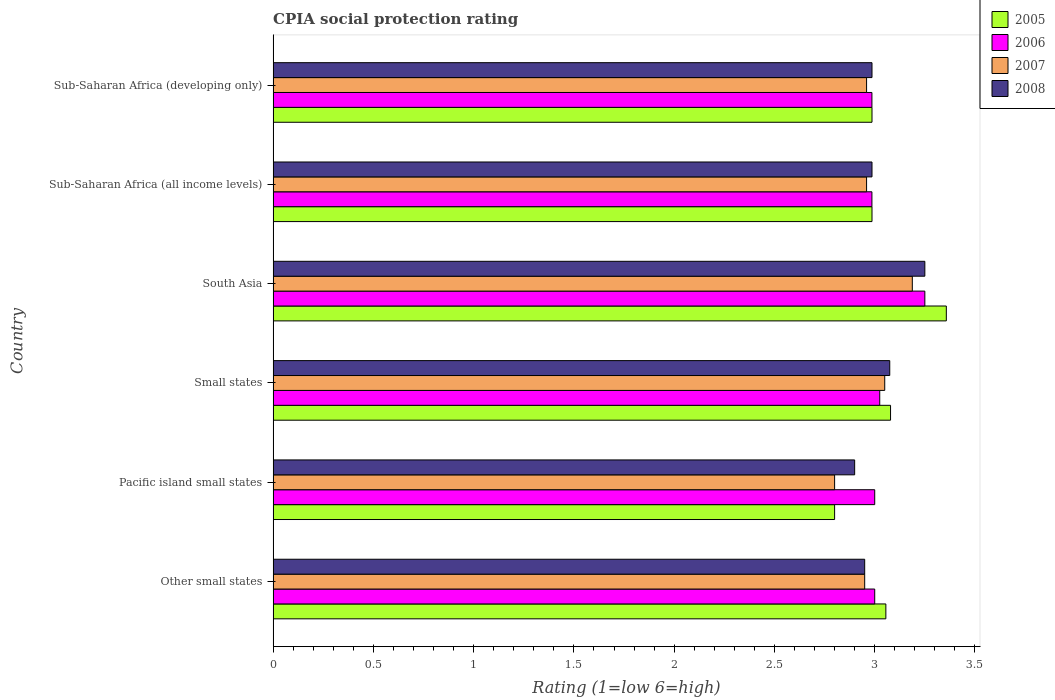How many groups of bars are there?
Your answer should be compact. 6. What is the label of the 6th group of bars from the top?
Offer a very short reply. Other small states. In how many cases, is the number of bars for a given country not equal to the number of legend labels?
Keep it short and to the point. 0. What is the CPIA rating in 2008 in Small states?
Give a very brief answer. 3.08. Across all countries, what is the maximum CPIA rating in 2007?
Your response must be concise. 3.19. Across all countries, what is the minimum CPIA rating in 2006?
Your answer should be compact. 2.99. In which country was the CPIA rating in 2008 maximum?
Offer a terse response. South Asia. In which country was the CPIA rating in 2005 minimum?
Offer a very short reply. Pacific island small states. What is the total CPIA rating in 2007 in the graph?
Your answer should be compact. 17.91. What is the difference between the CPIA rating in 2008 in Small states and that in Sub-Saharan Africa (developing only)?
Keep it short and to the point. 0.09. What is the difference between the CPIA rating in 2007 in South Asia and the CPIA rating in 2005 in Small states?
Provide a short and direct response. 0.11. What is the average CPIA rating in 2005 per country?
Provide a short and direct response. 3.04. What is the difference between the CPIA rating in 2007 and CPIA rating in 2005 in Other small states?
Give a very brief answer. -0.11. Is the CPIA rating in 2005 in Other small states less than that in Small states?
Make the answer very short. Yes. What is the difference between the highest and the second highest CPIA rating in 2007?
Keep it short and to the point. 0.14. What is the difference between the highest and the lowest CPIA rating in 2008?
Provide a short and direct response. 0.35. In how many countries, is the CPIA rating in 2006 greater than the average CPIA rating in 2006 taken over all countries?
Keep it short and to the point. 1. What does the 4th bar from the bottom in South Asia represents?
Provide a short and direct response. 2008. Is it the case that in every country, the sum of the CPIA rating in 2008 and CPIA rating in 2005 is greater than the CPIA rating in 2006?
Give a very brief answer. Yes. Are all the bars in the graph horizontal?
Provide a short and direct response. Yes. How many countries are there in the graph?
Keep it short and to the point. 6. Where does the legend appear in the graph?
Your answer should be very brief. Top right. What is the title of the graph?
Give a very brief answer. CPIA social protection rating. What is the label or title of the X-axis?
Your answer should be very brief. Rating (1=low 6=high). What is the Rating (1=low 6=high) in 2005 in Other small states?
Make the answer very short. 3.06. What is the Rating (1=low 6=high) of 2006 in Other small states?
Provide a succinct answer. 3. What is the Rating (1=low 6=high) of 2007 in Other small states?
Offer a terse response. 2.95. What is the Rating (1=low 6=high) of 2008 in Other small states?
Make the answer very short. 2.95. What is the Rating (1=low 6=high) in 2005 in Pacific island small states?
Your response must be concise. 2.8. What is the Rating (1=low 6=high) in 2006 in Pacific island small states?
Provide a succinct answer. 3. What is the Rating (1=low 6=high) in 2007 in Pacific island small states?
Offer a terse response. 2.8. What is the Rating (1=low 6=high) of 2008 in Pacific island small states?
Your answer should be very brief. 2.9. What is the Rating (1=low 6=high) in 2005 in Small states?
Provide a short and direct response. 3.08. What is the Rating (1=low 6=high) in 2006 in Small states?
Offer a very short reply. 3.02. What is the Rating (1=low 6=high) of 2007 in Small states?
Your answer should be compact. 3.05. What is the Rating (1=low 6=high) in 2008 in Small states?
Give a very brief answer. 3.08. What is the Rating (1=low 6=high) in 2005 in South Asia?
Give a very brief answer. 3.36. What is the Rating (1=low 6=high) of 2007 in South Asia?
Give a very brief answer. 3.19. What is the Rating (1=low 6=high) of 2005 in Sub-Saharan Africa (all income levels)?
Your answer should be compact. 2.99. What is the Rating (1=low 6=high) in 2006 in Sub-Saharan Africa (all income levels)?
Make the answer very short. 2.99. What is the Rating (1=low 6=high) of 2007 in Sub-Saharan Africa (all income levels)?
Give a very brief answer. 2.96. What is the Rating (1=low 6=high) in 2008 in Sub-Saharan Africa (all income levels)?
Provide a succinct answer. 2.99. What is the Rating (1=low 6=high) in 2005 in Sub-Saharan Africa (developing only)?
Your answer should be very brief. 2.99. What is the Rating (1=low 6=high) in 2006 in Sub-Saharan Africa (developing only)?
Provide a succinct answer. 2.99. What is the Rating (1=low 6=high) in 2007 in Sub-Saharan Africa (developing only)?
Give a very brief answer. 2.96. What is the Rating (1=low 6=high) of 2008 in Sub-Saharan Africa (developing only)?
Give a very brief answer. 2.99. Across all countries, what is the maximum Rating (1=low 6=high) of 2005?
Make the answer very short. 3.36. Across all countries, what is the maximum Rating (1=low 6=high) in 2006?
Provide a succinct answer. 3.25. Across all countries, what is the maximum Rating (1=low 6=high) in 2007?
Offer a terse response. 3.19. Across all countries, what is the maximum Rating (1=low 6=high) in 2008?
Offer a very short reply. 3.25. Across all countries, what is the minimum Rating (1=low 6=high) of 2006?
Keep it short and to the point. 2.99. Across all countries, what is the minimum Rating (1=low 6=high) of 2007?
Give a very brief answer. 2.8. Across all countries, what is the minimum Rating (1=low 6=high) of 2008?
Provide a succinct answer. 2.9. What is the total Rating (1=low 6=high) of 2005 in the graph?
Your answer should be very brief. 18.26. What is the total Rating (1=low 6=high) in 2006 in the graph?
Your answer should be compact. 18.25. What is the total Rating (1=low 6=high) in 2007 in the graph?
Your response must be concise. 17.91. What is the total Rating (1=low 6=high) in 2008 in the graph?
Give a very brief answer. 18.15. What is the difference between the Rating (1=low 6=high) of 2005 in Other small states and that in Pacific island small states?
Give a very brief answer. 0.26. What is the difference between the Rating (1=low 6=high) in 2006 in Other small states and that in Pacific island small states?
Your answer should be compact. 0. What is the difference between the Rating (1=low 6=high) of 2007 in Other small states and that in Pacific island small states?
Make the answer very short. 0.15. What is the difference between the Rating (1=low 6=high) of 2005 in Other small states and that in Small states?
Your answer should be compact. -0.02. What is the difference between the Rating (1=low 6=high) of 2006 in Other small states and that in Small states?
Provide a short and direct response. -0.03. What is the difference between the Rating (1=low 6=high) in 2008 in Other small states and that in Small states?
Your answer should be very brief. -0.12. What is the difference between the Rating (1=low 6=high) in 2005 in Other small states and that in South Asia?
Your response must be concise. -0.3. What is the difference between the Rating (1=low 6=high) in 2007 in Other small states and that in South Asia?
Make the answer very short. -0.24. What is the difference between the Rating (1=low 6=high) in 2008 in Other small states and that in South Asia?
Ensure brevity in your answer.  -0.3. What is the difference between the Rating (1=low 6=high) of 2005 in Other small states and that in Sub-Saharan Africa (all income levels)?
Your response must be concise. 0.07. What is the difference between the Rating (1=low 6=high) in 2006 in Other small states and that in Sub-Saharan Africa (all income levels)?
Your answer should be compact. 0.01. What is the difference between the Rating (1=low 6=high) in 2007 in Other small states and that in Sub-Saharan Africa (all income levels)?
Your answer should be compact. -0.01. What is the difference between the Rating (1=low 6=high) of 2008 in Other small states and that in Sub-Saharan Africa (all income levels)?
Ensure brevity in your answer.  -0.04. What is the difference between the Rating (1=low 6=high) of 2005 in Other small states and that in Sub-Saharan Africa (developing only)?
Provide a short and direct response. 0.07. What is the difference between the Rating (1=low 6=high) of 2006 in Other small states and that in Sub-Saharan Africa (developing only)?
Give a very brief answer. 0.01. What is the difference between the Rating (1=low 6=high) of 2007 in Other small states and that in Sub-Saharan Africa (developing only)?
Ensure brevity in your answer.  -0.01. What is the difference between the Rating (1=low 6=high) of 2008 in Other small states and that in Sub-Saharan Africa (developing only)?
Your response must be concise. -0.04. What is the difference between the Rating (1=low 6=high) in 2005 in Pacific island small states and that in Small states?
Provide a succinct answer. -0.28. What is the difference between the Rating (1=low 6=high) in 2006 in Pacific island small states and that in Small states?
Provide a succinct answer. -0.03. What is the difference between the Rating (1=low 6=high) in 2007 in Pacific island small states and that in Small states?
Keep it short and to the point. -0.25. What is the difference between the Rating (1=low 6=high) in 2008 in Pacific island small states and that in Small states?
Provide a succinct answer. -0.17. What is the difference between the Rating (1=low 6=high) of 2005 in Pacific island small states and that in South Asia?
Ensure brevity in your answer.  -0.56. What is the difference between the Rating (1=low 6=high) of 2007 in Pacific island small states and that in South Asia?
Keep it short and to the point. -0.39. What is the difference between the Rating (1=low 6=high) of 2008 in Pacific island small states and that in South Asia?
Your answer should be compact. -0.35. What is the difference between the Rating (1=low 6=high) in 2005 in Pacific island small states and that in Sub-Saharan Africa (all income levels)?
Offer a terse response. -0.19. What is the difference between the Rating (1=low 6=high) in 2006 in Pacific island small states and that in Sub-Saharan Africa (all income levels)?
Your answer should be compact. 0.01. What is the difference between the Rating (1=low 6=high) of 2007 in Pacific island small states and that in Sub-Saharan Africa (all income levels)?
Offer a very short reply. -0.16. What is the difference between the Rating (1=low 6=high) in 2008 in Pacific island small states and that in Sub-Saharan Africa (all income levels)?
Provide a succinct answer. -0.09. What is the difference between the Rating (1=low 6=high) in 2005 in Pacific island small states and that in Sub-Saharan Africa (developing only)?
Offer a terse response. -0.19. What is the difference between the Rating (1=low 6=high) of 2006 in Pacific island small states and that in Sub-Saharan Africa (developing only)?
Offer a very short reply. 0.01. What is the difference between the Rating (1=low 6=high) in 2007 in Pacific island small states and that in Sub-Saharan Africa (developing only)?
Make the answer very short. -0.16. What is the difference between the Rating (1=low 6=high) in 2008 in Pacific island small states and that in Sub-Saharan Africa (developing only)?
Your response must be concise. -0.09. What is the difference between the Rating (1=low 6=high) in 2005 in Small states and that in South Asia?
Your answer should be very brief. -0.28. What is the difference between the Rating (1=low 6=high) in 2006 in Small states and that in South Asia?
Your answer should be very brief. -0.23. What is the difference between the Rating (1=low 6=high) of 2007 in Small states and that in South Asia?
Your response must be concise. -0.14. What is the difference between the Rating (1=low 6=high) in 2008 in Small states and that in South Asia?
Provide a succinct answer. -0.17. What is the difference between the Rating (1=low 6=high) in 2005 in Small states and that in Sub-Saharan Africa (all income levels)?
Your answer should be very brief. 0.09. What is the difference between the Rating (1=low 6=high) in 2006 in Small states and that in Sub-Saharan Africa (all income levels)?
Give a very brief answer. 0.04. What is the difference between the Rating (1=low 6=high) in 2007 in Small states and that in Sub-Saharan Africa (all income levels)?
Your answer should be very brief. 0.09. What is the difference between the Rating (1=low 6=high) of 2008 in Small states and that in Sub-Saharan Africa (all income levels)?
Make the answer very short. 0.09. What is the difference between the Rating (1=low 6=high) in 2005 in Small states and that in Sub-Saharan Africa (developing only)?
Offer a terse response. 0.09. What is the difference between the Rating (1=low 6=high) of 2006 in Small states and that in Sub-Saharan Africa (developing only)?
Ensure brevity in your answer.  0.04. What is the difference between the Rating (1=low 6=high) in 2007 in Small states and that in Sub-Saharan Africa (developing only)?
Ensure brevity in your answer.  0.09. What is the difference between the Rating (1=low 6=high) of 2008 in Small states and that in Sub-Saharan Africa (developing only)?
Make the answer very short. 0.09. What is the difference between the Rating (1=low 6=high) of 2005 in South Asia and that in Sub-Saharan Africa (all income levels)?
Your answer should be compact. 0.37. What is the difference between the Rating (1=low 6=high) of 2006 in South Asia and that in Sub-Saharan Africa (all income levels)?
Make the answer very short. 0.26. What is the difference between the Rating (1=low 6=high) of 2007 in South Asia and that in Sub-Saharan Africa (all income levels)?
Your response must be concise. 0.23. What is the difference between the Rating (1=low 6=high) of 2008 in South Asia and that in Sub-Saharan Africa (all income levels)?
Your answer should be very brief. 0.26. What is the difference between the Rating (1=low 6=high) of 2005 in South Asia and that in Sub-Saharan Africa (developing only)?
Keep it short and to the point. 0.37. What is the difference between the Rating (1=low 6=high) in 2006 in South Asia and that in Sub-Saharan Africa (developing only)?
Your response must be concise. 0.26. What is the difference between the Rating (1=low 6=high) of 2007 in South Asia and that in Sub-Saharan Africa (developing only)?
Keep it short and to the point. 0.23. What is the difference between the Rating (1=low 6=high) of 2008 in South Asia and that in Sub-Saharan Africa (developing only)?
Give a very brief answer. 0.26. What is the difference between the Rating (1=low 6=high) of 2005 in Sub-Saharan Africa (all income levels) and that in Sub-Saharan Africa (developing only)?
Give a very brief answer. 0. What is the difference between the Rating (1=low 6=high) in 2006 in Sub-Saharan Africa (all income levels) and that in Sub-Saharan Africa (developing only)?
Give a very brief answer. 0. What is the difference between the Rating (1=low 6=high) in 2007 in Sub-Saharan Africa (all income levels) and that in Sub-Saharan Africa (developing only)?
Offer a terse response. 0. What is the difference between the Rating (1=low 6=high) of 2005 in Other small states and the Rating (1=low 6=high) of 2006 in Pacific island small states?
Ensure brevity in your answer.  0.06. What is the difference between the Rating (1=low 6=high) in 2005 in Other small states and the Rating (1=low 6=high) in 2007 in Pacific island small states?
Provide a succinct answer. 0.26. What is the difference between the Rating (1=low 6=high) of 2005 in Other small states and the Rating (1=low 6=high) of 2008 in Pacific island small states?
Provide a short and direct response. 0.16. What is the difference between the Rating (1=low 6=high) of 2006 in Other small states and the Rating (1=low 6=high) of 2008 in Pacific island small states?
Your response must be concise. 0.1. What is the difference between the Rating (1=low 6=high) of 2005 in Other small states and the Rating (1=low 6=high) of 2006 in Small states?
Make the answer very short. 0.03. What is the difference between the Rating (1=low 6=high) of 2005 in Other small states and the Rating (1=low 6=high) of 2007 in Small states?
Your answer should be compact. 0.01. What is the difference between the Rating (1=low 6=high) of 2005 in Other small states and the Rating (1=low 6=high) of 2008 in Small states?
Your answer should be compact. -0.02. What is the difference between the Rating (1=low 6=high) of 2006 in Other small states and the Rating (1=low 6=high) of 2007 in Small states?
Provide a succinct answer. -0.05. What is the difference between the Rating (1=low 6=high) of 2006 in Other small states and the Rating (1=low 6=high) of 2008 in Small states?
Your answer should be very brief. -0.07. What is the difference between the Rating (1=low 6=high) in 2007 in Other small states and the Rating (1=low 6=high) in 2008 in Small states?
Your response must be concise. -0.12. What is the difference between the Rating (1=low 6=high) in 2005 in Other small states and the Rating (1=low 6=high) in 2006 in South Asia?
Your answer should be very brief. -0.19. What is the difference between the Rating (1=low 6=high) of 2005 in Other small states and the Rating (1=low 6=high) of 2007 in South Asia?
Offer a very short reply. -0.13. What is the difference between the Rating (1=low 6=high) of 2005 in Other small states and the Rating (1=low 6=high) of 2008 in South Asia?
Give a very brief answer. -0.19. What is the difference between the Rating (1=low 6=high) of 2006 in Other small states and the Rating (1=low 6=high) of 2007 in South Asia?
Your response must be concise. -0.19. What is the difference between the Rating (1=low 6=high) of 2006 in Other small states and the Rating (1=low 6=high) of 2008 in South Asia?
Your answer should be compact. -0.25. What is the difference between the Rating (1=low 6=high) of 2007 in Other small states and the Rating (1=low 6=high) of 2008 in South Asia?
Your response must be concise. -0.3. What is the difference between the Rating (1=low 6=high) in 2005 in Other small states and the Rating (1=low 6=high) in 2006 in Sub-Saharan Africa (all income levels)?
Your answer should be compact. 0.07. What is the difference between the Rating (1=low 6=high) of 2005 in Other small states and the Rating (1=low 6=high) of 2007 in Sub-Saharan Africa (all income levels)?
Offer a very short reply. 0.1. What is the difference between the Rating (1=low 6=high) of 2005 in Other small states and the Rating (1=low 6=high) of 2008 in Sub-Saharan Africa (all income levels)?
Make the answer very short. 0.07. What is the difference between the Rating (1=low 6=high) of 2006 in Other small states and the Rating (1=low 6=high) of 2007 in Sub-Saharan Africa (all income levels)?
Offer a terse response. 0.04. What is the difference between the Rating (1=low 6=high) in 2006 in Other small states and the Rating (1=low 6=high) in 2008 in Sub-Saharan Africa (all income levels)?
Give a very brief answer. 0.01. What is the difference between the Rating (1=low 6=high) in 2007 in Other small states and the Rating (1=low 6=high) in 2008 in Sub-Saharan Africa (all income levels)?
Your answer should be very brief. -0.04. What is the difference between the Rating (1=low 6=high) in 2005 in Other small states and the Rating (1=low 6=high) in 2006 in Sub-Saharan Africa (developing only)?
Keep it short and to the point. 0.07. What is the difference between the Rating (1=low 6=high) in 2005 in Other small states and the Rating (1=low 6=high) in 2007 in Sub-Saharan Africa (developing only)?
Ensure brevity in your answer.  0.1. What is the difference between the Rating (1=low 6=high) of 2005 in Other small states and the Rating (1=low 6=high) of 2008 in Sub-Saharan Africa (developing only)?
Your answer should be very brief. 0.07. What is the difference between the Rating (1=low 6=high) in 2006 in Other small states and the Rating (1=low 6=high) in 2007 in Sub-Saharan Africa (developing only)?
Provide a short and direct response. 0.04. What is the difference between the Rating (1=low 6=high) of 2006 in Other small states and the Rating (1=low 6=high) of 2008 in Sub-Saharan Africa (developing only)?
Make the answer very short. 0.01. What is the difference between the Rating (1=low 6=high) of 2007 in Other small states and the Rating (1=low 6=high) of 2008 in Sub-Saharan Africa (developing only)?
Give a very brief answer. -0.04. What is the difference between the Rating (1=low 6=high) in 2005 in Pacific island small states and the Rating (1=low 6=high) in 2006 in Small states?
Your response must be concise. -0.23. What is the difference between the Rating (1=low 6=high) in 2005 in Pacific island small states and the Rating (1=low 6=high) in 2008 in Small states?
Your answer should be compact. -0.28. What is the difference between the Rating (1=low 6=high) in 2006 in Pacific island small states and the Rating (1=low 6=high) in 2008 in Small states?
Keep it short and to the point. -0.07. What is the difference between the Rating (1=low 6=high) of 2007 in Pacific island small states and the Rating (1=low 6=high) of 2008 in Small states?
Ensure brevity in your answer.  -0.28. What is the difference between the Rating (1=low 6=high) in 2005 in Pacific island small states and the Rating (1=low 6=high) in 2006 in South Asia?
Your answer should be compact. -0.45. What is the difference between the Rating (1=low 6=high) of 2005 in Pacific island small states and the Rating (1=low 6=high) of 2007 in South Asia?
Make the answer very short. -0.39. What is the difference between the Rating (1=low 6=high) of 2005 in Pacific island small states and the Rating (1=low 6=high) of 2008 in South Asia?
Provide a succinct answer. -0.45. What is the difference between the Rating (1=low 6=high) in 2006 in Pacific island small states and the Rating (1=low 6=high) in 2007 in South Asia?
Your answer should be compact. -0.19. What is the difference between the Rating (1=low 6=high) in 2006 in Pacific island small states and the Rating (1=low 6=high) in 2008 in South Asia?
Your answer should be compact. -0.25. What is the difference between the Rating (1=low 6=high) in 2007 in Pacific island small states and the Rating (1=low 6=high) in 2008 in South Asia?
Keep it short and to the point. -0.45. What is the difference between the Rating (1=low 6=high) in 2005 in Pacific island small states and the Rating (1=low 6=high) in 2006 in Sub-Saharan Africa (all income levels)?
Provide a succinct answer. -0.19. What is the difference between the Rating (1=low 6=high) in 2005 in Pacific island small states and the Rating (1=low 6=high) in 2007 in Sub-Saharan Africa (all income levels)?
Your answer should be compact. -0.16. What is the difference between the Rating (1=low 6=high) in 2005 in Pacific island small states and the Rating (1=low 6=high) in 2008 in Sub-Saharan Africa (all income levels)?
Your answer should be compact. -0.19. What is the difference between the Rating (1=low 6=high) of 2006 in Pacific island small states and the Rating (1=low 6=high) of 2007 in Sub-Saharan Africa (all income levels)?
Your answer should be compact. 0.04. What is the difference between the Rating (1=low 6=high) in 2006 in Pacific island small states and the Rating (1=low 6=high) in 2008 in Sub-Saharan Africa (all income levels)?
Make the answer very short. 0.01. What is the difference between the Rating (1=low 6=high) in 2007 in Pacific island small states and the Rating (1=low 6=high) in 2008 in Sub-Saharan Africa (all income levels)?
Provide a succinct answer. -0.19. What is the difference between the Rating (1=low 6=high) of 2005 in Pacific island small states and the Rating (1=low 6=high) of 2006 in Sub-Saharan Africa (developing only)?
Keep it short and to the point. -0.19. What is the difference between the Rating (1=low 6=high) of 2005 in Pacific island small states and the Rating (1=low 6=high) of 2007 in Sub-Saharan Africa (developing only)?
Offer a terse response. -0.16. What is the difference between the Rating (1=low 6=high) in 2005 in Pacific island small states and the Rating (1=low 6=high) in 2008 in Sub-Saharan Africa (developing only)?
Offer a very short reply. -0.19. What is the difference between the Rating (1=low 6=high) in 2006 in Pacific island small states and the Rating (1=low 6=high) in 2007 in Sub-Saharan Africa (developing only)?
Your answer should be compact. 0.04. What is the difference between the Rating (1=low 6=high) of 2006 in Pacific island small states and the Rating (1=low 6=high) of 2008 in Sub-Saharan Africa (developing only)?
Your answer should be very brief. 0.01. What is the difference between the Rating (1=low 6=high) of 2007 in Pacific island small states and the Rating (1=low 6=high) of 2008 in Sub-Saharan Africa (developing only)?
Make the answer very short. -0.19. What is the difference between the Rating (1=low 6=high) of 2005 in Small states and the Rating (1=low 6=high) of 2006 in South Asia?
Your answer should be compact. -0.17. What is the difference between the Rating (1=low 6=high) of 2005 in Small states and the Rating (1=low 6=high) of 2007 in South Asia?
Your answer should be very brief. -0.11. What is the difference between the Rating (1=low 6=high) in 2005 in Small states and the Rating (1=low 6=high) in 2008 in South Asia?
Offer a terse response. -0.17. What is the difference between the Rating (1=low 6=high) in 2006 in Small states and the Rating (1=low 6=high) in 2007 in South Asia?
Your answer should be compact. -0.16. What is the difference between the Rating (1=low 6=high) in 2006 in Small states and the Rating (1=low 6=high) in 2008 in South Asia?
Ensure brevity in your answer.  -0.23. What is the difference between the Rating (1=low 6=high) in 2005 in Small states and the Rating (1=low 6=high) in 2006 in Sub-Saharan Africa (all income levels)?
Your response must be concise. 0.09. What is the difference between the Rating (1=low 6=high) in 2005 in Small states and the Rating (1=low 6=high) in 2007 in Sub-Saharan Africa (all income levels)?
Give a very brief answer. 0.12. What is the difference between the Rating (1=low 6=high) of 2005 in Small states and the Rating (1=low 6=high) of 2008 in Sub-Saharan Africa (all income levels)?
Your answer should be compact. 0.09. What is the difference between the Rating (1=low 6=high) in 2006 in Small states and the Rating (1=low 6=high) in 2007 in Sub-Saharan Africa (all income levels)?
Ensure brevity in your answer.  0.07. What is the difference between the Rating (1=low 6=high) of 2006 in Small states and the Rating (1=low 6=high) of 2008 in Sub-Saharan Africa (all income levels)?
Keep it short and to the point. 0.04. What is the difference between the Rating (1=low 6=high) in 2007 in Small states and the Rating (1=low 6=high) in 2008 in Sub-Saharan Africa (all income levels)?
Your answer should be very brief. 0.06. What is the difference between the Rating (1=low 6=high) in 2005 in Small states and the Rating (1=low 6=high) in 2006 in Sub-Saharan Africa (developing only)?
Provide a succinct answer. 0.09. What is the difference between the Rating (1=low 6=high) in 2005 in Small states and the Rating (1=low 6=high) in 2007 in Sub-Saharan Africa (developing only)?
Provide a short and direct response. 0.12. What is the difference between the Rating (1=low 6=high) in 2005 in Small states and the Rating (1=low 6=high) in 2008 in Sub-Saharan Africa (developing only)?
Your answer should be very brief. 0.09. What is the difference between the Rating (1=low 6=high) in 2006 in Small states and the Rating (1=low 6=high) in 2007 in Sub-Saharan Africa (developing only)?
Your response must be concise. 0.07. What is the difference between the Rating (1=low 6=high) of 2006 in Small states and the Rating (1=low 6=high) of 2008 in Sub-Saharan Africa (developing only)?
Ensure brevity in your answer.  0.04. What is the difference between the Rating (1=low 6=high) in 2007 in Small states and the Rating (1=low 6=high) in 2008 in Sub-Saharan Africa (developing only)?
Give a very brief answer. 0.06. What is the difference between the Rating (1=low 6=high) of 2005 in South Asia and the Rating (1=low 6=high) of 2006 in Sub-Saharan Africa (all income levels)?
Your answer should be very brief. 0.37. What is the difference between the Rating (1=low 6=high) in 2005 in South Asia and the Rating (1=low 6=high) in 2007 in Sub-Saharan Africa (all income levels)?
Keep it short and to the point. 0.4. What is the difference between the Rating (1=low 6=high) of 2005 in South Asia and the Rating (1=low 6=high) of 2008 in Sub-Saharan Africa (all income levels)?
Your answer should be very brief. 0.37. What is the difference between the Rating (1=low 6=high) in 2006 in South Asia and the Rating (1=low 6=high) in 2007 in Sub-Saharan Africa (all income levels)?
Offer a very short reply. 0.29. What is the difference between the Rating (1=low 6=high) of 2006 in South Asia and the Rating (1=low 6=high) of 2008 in Sub-Saharan Africa (all income levels)?
Offer a very short reply. 0.26. What is the difference between the Rating (1=low 6=high) of 2007 in South Asia and the Rating (1=low 6=high) of 2008 in Sub-Saharan Africa (all income levels)?
Offer a very short reply. 0.2. What is the difference between the Rating (1=low 6=high) of 2005 in South Asia and the Rating (1=low 6=high) of 2006 in Sub-Saharan Africa (developing only)?
Ensure brevity in your answer.  0.37. What is the difference between the Rating (1=low 6=high) in 2005 in South Asia and the Rating (1=low 6=high) in 2007 in Sub-Saharan Africa (developing only)?
Offer a terse response. 0.4. What is the difference between the Rating (1=low 6=high) of 2005 in South Asia and the Rating (1=low 6=high) of 2008 in Sub-Saharan Africa (developing only)?
Provide a succinct answer. 0.37. What is the difference between the Rating (1=low 6=high) in 2006 in South Asia and the Rating (1=low 6=high) in 2007 in Sub-Saharan Africa (developing only)?
Offer a terse response. 0.29. What is the difference between the Rating (1=low 6=high) in 2006 in South Asia and the Rating (1=low 6=high) in 2008 in Sub-Saharan Africa (developing only)?
Make the answer very short. 0.26. What is the difference between the Rating (1=low 6=high) of 2007 in South Asia and the Rating (1=low 6=high) of 2008 in Sub-Saharan Africa (developing only)?
Offer a very short reply. 0.2. What is the difference between the Rating (1=low 6=high) in 2005 in Sub-Saharan Africa (all income levels) and the Rating (1=low 6=high) in 2006 in Sub-Saharan Africa (developing only)?
Keep it short and to the point. 0. What is the difference between the Rating (1=low 6=high) of 2005 in Sub-Saharan Africa (all income levels) and the Rating (1=low 6=high) of 2007 in Sub-Saharan Africa (developing only)?
Ensure brevity in your answer.  0.03. What is the difference between the Rating (1=low 6=high) of 2006 in Sub-Saharan Africa (all income levels) and the Rating (1=low 6=high) of 2007 in Sub-Saharan Africa (developing only)?
Provide a short and direct response. 0.03. What is the difference between the Rating (1=low 6=high) in 2006 in Sub-Saharan Africa (all income levels) and the Rating (1=low 6=high) in 2008 in Sub-Saharan Africa (developing only)?
Offer a terse response. -0. What is the difference between the Rating (1=low 6=high) in 2007 in Sub-Saharan Africa (all income levels) and the Rating (1=low 6=high) in 2008 in Sub-Saharan Africa (developing only)?
Your answer should be compact. -0.03. What is the average Rating (1=low 6=high) in 2005 per country?
Keep it short and to the point. 3.04. What is the average Rating (1=low 6=high) of 2006 per country?
Your answer should be very brief. 3.04. What is the average Rating (1=low 6=high) in 2007 per country?
Your answer should be very brief. 2.98. What is the average Rating (1=low 6=high) of 2008 per country?
Make the answer very short. 3.02. What is the difference between the Rating (1=low 6=high) in 2005 and Rating (1=low 6=high) in 2006 in Other small states?
Your answer should be very brief. 0.06. What is the difference between the Rating (1=low 6=high) of 2005 and Rating (1=low 6=high) of 2007 in Other small states?
Make the answer very short. 0.11. What is the difference between the Rating (1=low 6=high) in 2005 and Rating (1=low 6=high) in 2008 in Other small states?
Ensure brevity in your answer.  0.11. What is the difference between the Rating (1=low 6=high) in 2006 and Rating (1=low 6=high) in 2007 in Other small states?
Keep it short and to the point. 0.05. What is the difference between the Rating (1=low 6=high) of 2006 and Rating (1=low 6=high) of 2008 in Other small states?
Keep it short and to the point. 0.05. What is the difference between the Rating (1=low 6=high) in 2005 and Rating (1=low 6=high) in 2008 in Pacific island small states?
Offer a very short reply. -0.1. What is the difference between the Rating (1=low 6=high) in 2006 and Rating (1=low 6=high) in 2008 in Pacific island small states?
Provide a short and direct response. 0.1. What is the difference between the Rating (1=low 6=high) in 2005 and Rating (1=low 6=high) in 2006 in Small states?
Ensure brevity in your answer.  0.05. What is the difference between the Rating (1=low 6=high) in 2005 and Rating (1=low 6=high) in 2007 in Small states?
Give a very brief answer. 0.03. What is the difference between the Rating (1=low 6=high) in 2005 and Rating (1=low 6=high) in 2008 in Small states?
Your answer should be very brief. 0. What is the difference between the Rating (1=low 6=high) in 2006 and Rating (1=low 6=high) in 2007 in Small states?
Offer a terse response. -0.03. What is the difference between the Rating (1=low 6=high) in 2006 and Rating (1=low 6=high) in 2008 in Small states?
Provide a succinct answer. -0.05. What is the difference between the Rating (1=low 6=high) of 2007 and Rating (1=low 6=high) of 2008 in Small states?
Your response must be concise. -0.03. What is the difference between the Rating (1=low 6=high) in 2005 and Rating (1=low 6=high) in 2006 in South Asia?
Offer a very short reply. 0.11. What is the difference between the Rating (1=low 6=high) in 2005 and Rating (1=low 6=high) in 2007 in South Asia?
Keep it short and to the point. 0.17. What is the difference between the Rating (1=low 6=high) of 2005 and Rating (1=low 6=high) of 2008 in South Asia?
Your answer should be very brief. 0.11. What is the difference between the Rating (1=low 6=high) in 2006 and Rating (1=low 6=high) in 2007 in South Asia?
Keep it short and to the point. 0.06. What is the difference between the Rating (1=low 6=high) of 2006 and Rating (1=low 6=high) of 2008 in South Asia?
Ensure brevity in your answer.  0. What is the difference between the Rating (1=low 6=high) of 2007 and Rating (1=low 6=high) of 2008 in South Asia?
Your answer should be very brief. -0.06. What is the difference between the Rating (1=low 6=high) of 2005 and Rating (1=low 6=high) of 2007 in Sub-Saharan Africa (all income levels)?
Your answer should be very brief. 0.03. What is the difference between the Rating (1=low 6=high) of 2006 and Rating (1=low 6=high) of 2007 in Sub-Saharan Africa (all income levels)?
Your response must be concise. 0.03. What is the difference between the Rating (1=low 6=high) in 2006 and Rating (1=low 6=high) in 2008 in Sub-Saharan Africa (all income levels)?
Offer a very short reply. -0. What is the difference between the Rating (1=low 6=high) of 2007 and Rating (1=low 6=high) of 2008 in Sub-Saharan Africa (all income levels)?
Keep it short and to the point. -0.03. What is the difference between the Rating (1=low 6=high) in 2005 and Rating (1=low 6=high) in 2006 in Sub-Saharan Africa (developing only)?
Provide a short and direct response. 0. What is the difference between the Rating (1=low 6=high) of 2005 and Rating (1=low 6=high) of 2007 in Sub-Saharan Africa (developing only)?
Offer a very short reply. 0.03. What is the difference between the Rating (1=low 6=high) of 2006 and Rating (1=low 6=high) of 2007 in Sub-Saharan Africa (developing only)?
Your answer should be very brief. 0.03. What is the difference between the Rating (1=low 6=high) of 2006 and Rating (1=low 6=high) of 2008 in Sub-Saharan Africa (developing only)?
Provide a short and direct response. -0. What is the difference between the Rating (1=low 6=high) in 2007 and Rating (1=low 6=high) in 2008 in Sub-Saharan Africa (developing only)?
Make the answer very short. -0.03. What is the ratio of the Rating (1=low 6=high) in 2005 in Other small states to that in Pacific island small states?
Provide a short and direct response. 1.09. What is the ratio of the Rating (1=low 6=high) in 2006 in Other small states to that in Pacific island small states?
Your answer should be compact. 1. What is the ratio of the Rating (1=low 6=high) in 2007 in Other small states to that in Pacific island small states?
Provide a short and direct response. 1.05. What is the ratio of the Rating (1=low 6=high) in 2008 in Other small states to that in Pacific island small states?
Give a very brief answer. 1.02. What is the ratio of the Rating (1=low 6=high) of 2005 in Other small states to that in Small states?
Make the answer very short. 0.99. What is the ratio of the Rating (1=low 6=high) in 2007 in Other small states to that in Small states?
Give a very brief answer. 0.97. What is the ratio of the Rating (1=low 6=high) in 2008 in Other small states to that in Small states?
Offer a very short reply. 0.96. What is the ratio of the Rating (1=low 6=high) in 2005 in Other small states to that in South Asia?
Make the answer very short. 0.91. What is the ratio of the Rating (1=low 6=high) of 2007 in Other small states to that in South Asia?
Ensure brevity in your answer.  0.93. What is the ratio of the Rating (1=low 6=high) of 2008 in Other small states to that in South Asia?
Offer a terse response. 0.91. What is the ratio of the Rating (1=low 6=high) of 2005 in Other small states to that in Sub-Saharan Africa (all income levels)?
Provide a short and direct response. 1.02. What is the ratio of the Rating (1=low 6=high) in 2007 in Other small states to that in Sub-Saharan Africa (all income levels)?
Make the answer very short. 1. What is the ratio of the Rating (1=low 6=high) in 2005 in Other small states to that in Sub-Saharan Africa (developing only)?
Your answer should be compact. 1.02. What is the ratio of the Rating (1=low 6=high) of 2007 in Other small states to that in Sub-Saharan Africa (developing only)?
Offer a very short reply. 1. What is the ratio of the Rating (1=low 6=high) of 2008 in Other small states to that in Sub-Saharan Africa (developing only)?
Offer a very short reply. 0.99. What is the ratio of the Rating (1=low 6=high) of 2005 in Pacific island small states to that in Small states?
Make the answer very short. 0.91. What is the ratio of the Rating (1=low 6=high) of 2007 in Pacific island small states to that in Small states?
Your response must be concise. 0.92. What is the ratio of the Rating (1=low 6=high) in 2008 in Pacific island small states to that in Small states?
Your answer should be compact. 0.94. What is the ratio of the Rating (1=low 6=high) in 2005 in Pacific island small states to that in South Asia?
Keep it short and to the point. 0.83. What is the ratio of the Rating (1=low 6=high) of 2006 in Pacific island small states to that in South Asia?
Offer a very short reply. 0.92. What is the ratio of the Rating (1=low 6=high) of 2007 in Pacific island small states to that in South Asia?
Provide a short and direct response. 0.88. What is the ratio of the Rating (1=low 6=high) of 2008 in Pacific island small states to that in South Asia?
Ensure brevity in your answer.  0.89. What is the ratio of the Rating (1=low 6=high) of 2005 in Pacific island small states to that in Sub-Saharan Africa (all income levels)?
Offer a terse response. 0.94. What is the ratio of the Rating (1=low 6=high) in 2006 in Pacific island small states to that in Sub-Saharan Africa (all income levels)?
Make the answer very short. 1. What is the ratio of the Rating (1=low 6=high) in 2007 in Pacific island small states to that in Sub-Saharan Africa (all income levels)?
Offer a terse response. 0.95. What is the ratio of the Rating (1=low 6=high) of 2008 in Pacific island small states to that in Sub-Saharan Africa (all income levels)?
Offer a very short reply. 0.97. What is the ratio of the Rating (1=low 6=high) in 2005 in Pacific island small states to that in Sub-Saharan Africa (developing only)?
Provide a succinct answer. 0.94. What is the ratio of the Rating (1=low 6=high) of 2006 in Pacific island small states to that in Sub-Saharan Africa (developing only)?
Make the answer very short. 1. What is the ratio of the Rating (1=low 6=high) in 2007 in Pacific island small states to that in Sub-Saharan Africa (developing only)?
Your answer should be very brief. 0.95. What is the ratio of the Rating (1=low 6=high) of 2008 in Pacific island small states to that in Sub-Saharan Africa (developing only)?
Provide a succinct answer. 0.97. What is the ratio of the Rating (1=low 6=high) of 2005 in Small states to that in South Asia?
Ensure brevity in your answer.  0.92. What is the ratio of the Rating (1=low 6=high) of 2006 in Small states to that in South Asia?
Provide a short and direct response. 0.93. What is the ratio of the Rating (1=low 6=high) of 2007 in Small states to that in South Asia?
Give a very brief answer. 0.96. What is the ratio of the Rating (1=low 6=high) in 2008 in Small states to that in South Asia?
Your answer should be very brief. 0.95. What is the ratio of the Rating (1=low 6=high) of 2005 in Small states to that in Sub-Saharan Africa (all income levels)?
Your response must be concise. 1.03. What is the ratio of the Rating (1=low 6=high) in 2007 in Small states to that in Sub-Saharan Africa (all income levels)?
Ensure brevity in your answer.  1.03. What is the ratio of the Rating (1=low 6=high) of 2008 in Small states to that in Sub-Saharan Africa (all income levels)?
Keep it short and to the point. 1.03. What is the ratio of the Rating (1=low 6=high) in 2005 in Small states to that in Sub-Saharan Africa (developing only)?
Your answer should be very brief. 1.03. What is the ratio of the Rating (1=low 6=high) in 2006 in Small states to that in Sub-Saharan Africa (developing only)?
Provide a succinct answer. 1.01. What is the ratio of the Rating (1=low 6=high) of 2007 in Small states to that in Sub-Saharan Africa (developing only)?
Offer a very short reply. 1.03. What is the ratio of the Rating (1=low 6=high) in 2008 in Small states to that in Sub-Saharan Africa (developing only)?
Offer a terse response. 1.03. What is the ratio of the Rating (1=low 6=high) in 2005 in South Asia to that in Sub-Saharan Africa (all income levels)?
Your answer should be very brief. 1.12. What is the ratio of the Rating (1=low 6=high) of 2006 in South Asia to that in Sub-Saharan Africa (all income levels)?
Make the answer very short. 1.09. What is the ratio of the Rating (1=low 6=high) of 2007 in South Asia to that in Sub-Saharan Africa (all income levels)?
Provide a short and direct response. 1.08. What is the ratio of the Rating (1=low 6=high) of 2008 in South Asia to that in Sub-Saharan Africa (all income levels)?
Offer a very short reply. 1.09. What is the ratio of the Rating (1=low 6=high) of 2005 in South Asia to that in Sub-Saharan Africa (developing only)?
Offer a very short reply. 1.12. What is the ratio of the Rating (1=low 6=high) in 2006 in South Asia to that in Sub-Saharan Africa (developing only)?
Your response must be concise. 1.09. What is the ratio of the Rating (1=low 6=high) in 2007 in South Asia to that in Sub-Saharan Africa (developing only)?
Your response must be concise. 1.08. What is the ratio of the Rating (1=low 6=high) of 2008 in South Asia to that in Sub-Saharan Africa (developing only)?
Offer a terse response. 1.09. What is the ratio of the Rating (1=low 6=high) of 2007 in Sub-Saharan Africa (all income levels) to that in Sub-Saharan Africa (developing only)?
Offer a very short reply. 1. What is the difference between the highest and the second highest Rating (1=low 6=high) of 2005?
Offer a terse response. 0.28. What is the difference between the highest and the second highest Rating (1=low 6=high) in 2006?
Your answer should be compact. 0.23. What is the difference between the highest and the second highest Rating (1=low 6=high) of 2007?
Provide a succinct answer. 0.14. What is the difference between the highest and the second highest Rating (1=low 6=high) of 2008?
Provide a short and direct response. 0.17. What is the difference between the highest and the lowest Rating (1=low 6=high) of 2005?
Provide a short and direct response. 0.56. What is the difference between the highest and the lowest Rating (1=low 6=high) of 2006?
Your answer should be very brief. 0.26. What is the difference between the highest and the lowest Rating (1=low 6=high) in 2007?
Provide a short and direct response. 0.39. 